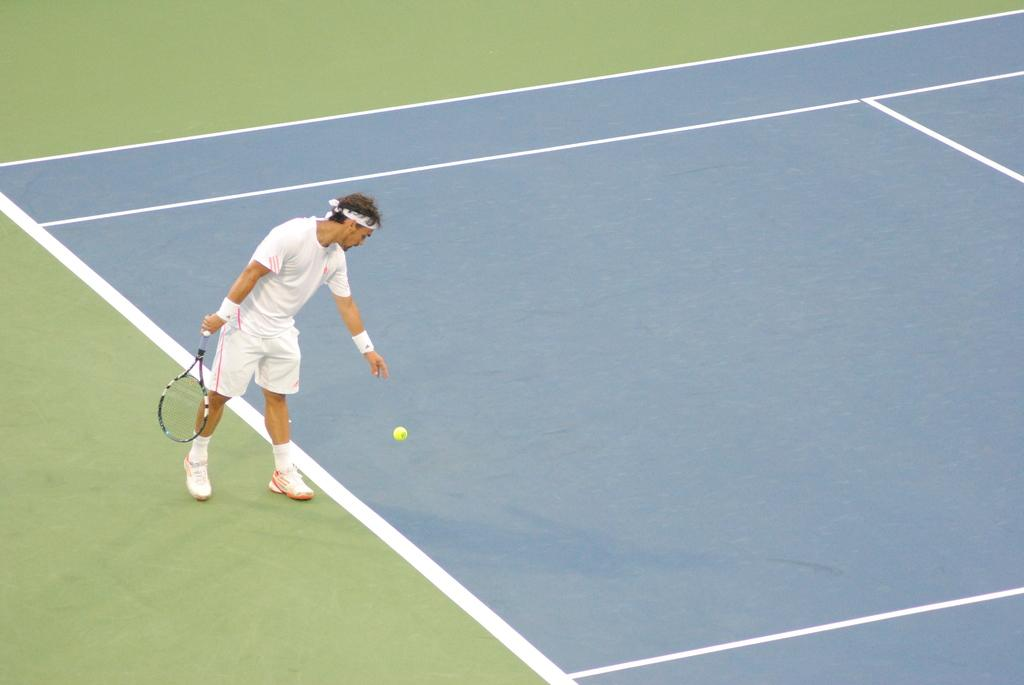Who is the main subject in the image? There is a man in the image. What is the man doing in the image? The man is playing tennis. What is the man wearing in the image? The man is wearing a white dress. Where is the man playing tennis? The setting is a tennis court. What type of oven is visible in the image? There is no oven present in the image. How does the print on the man's dress relate to the game of tennis? The man's dress does not have a print, and therefore there is no relation to the game of tennis. 